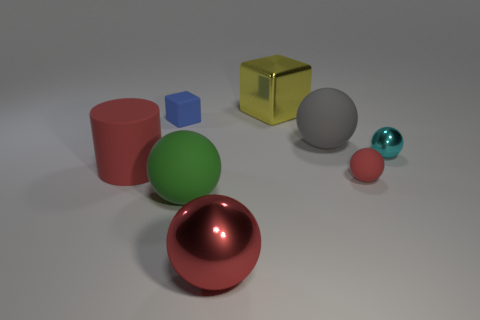Add 2 yellow blocks. How many objects exist? 10 Subtract all red spheres. How many spheres are left? 3 Subtract all cylinders. How many objects are left? 7 Subtract all red balls. How many balls are left? 3 Subtract all green cubes. Subtract all cyan cylinders. How many cubes are left? 2 Subtract 0 brown blocks. How many objects are left? 8 Subtract all green spheres. How many cyan cubes are left? 0 Subtract all large red matte objects. Subtract all small red spheres. How many objects are left? 6 Add 1 yellow shiny cubes. How many yellow shiny cubes are left? 2 Add 5 yellow metal objects. How many yellow metal objects exist? 6 